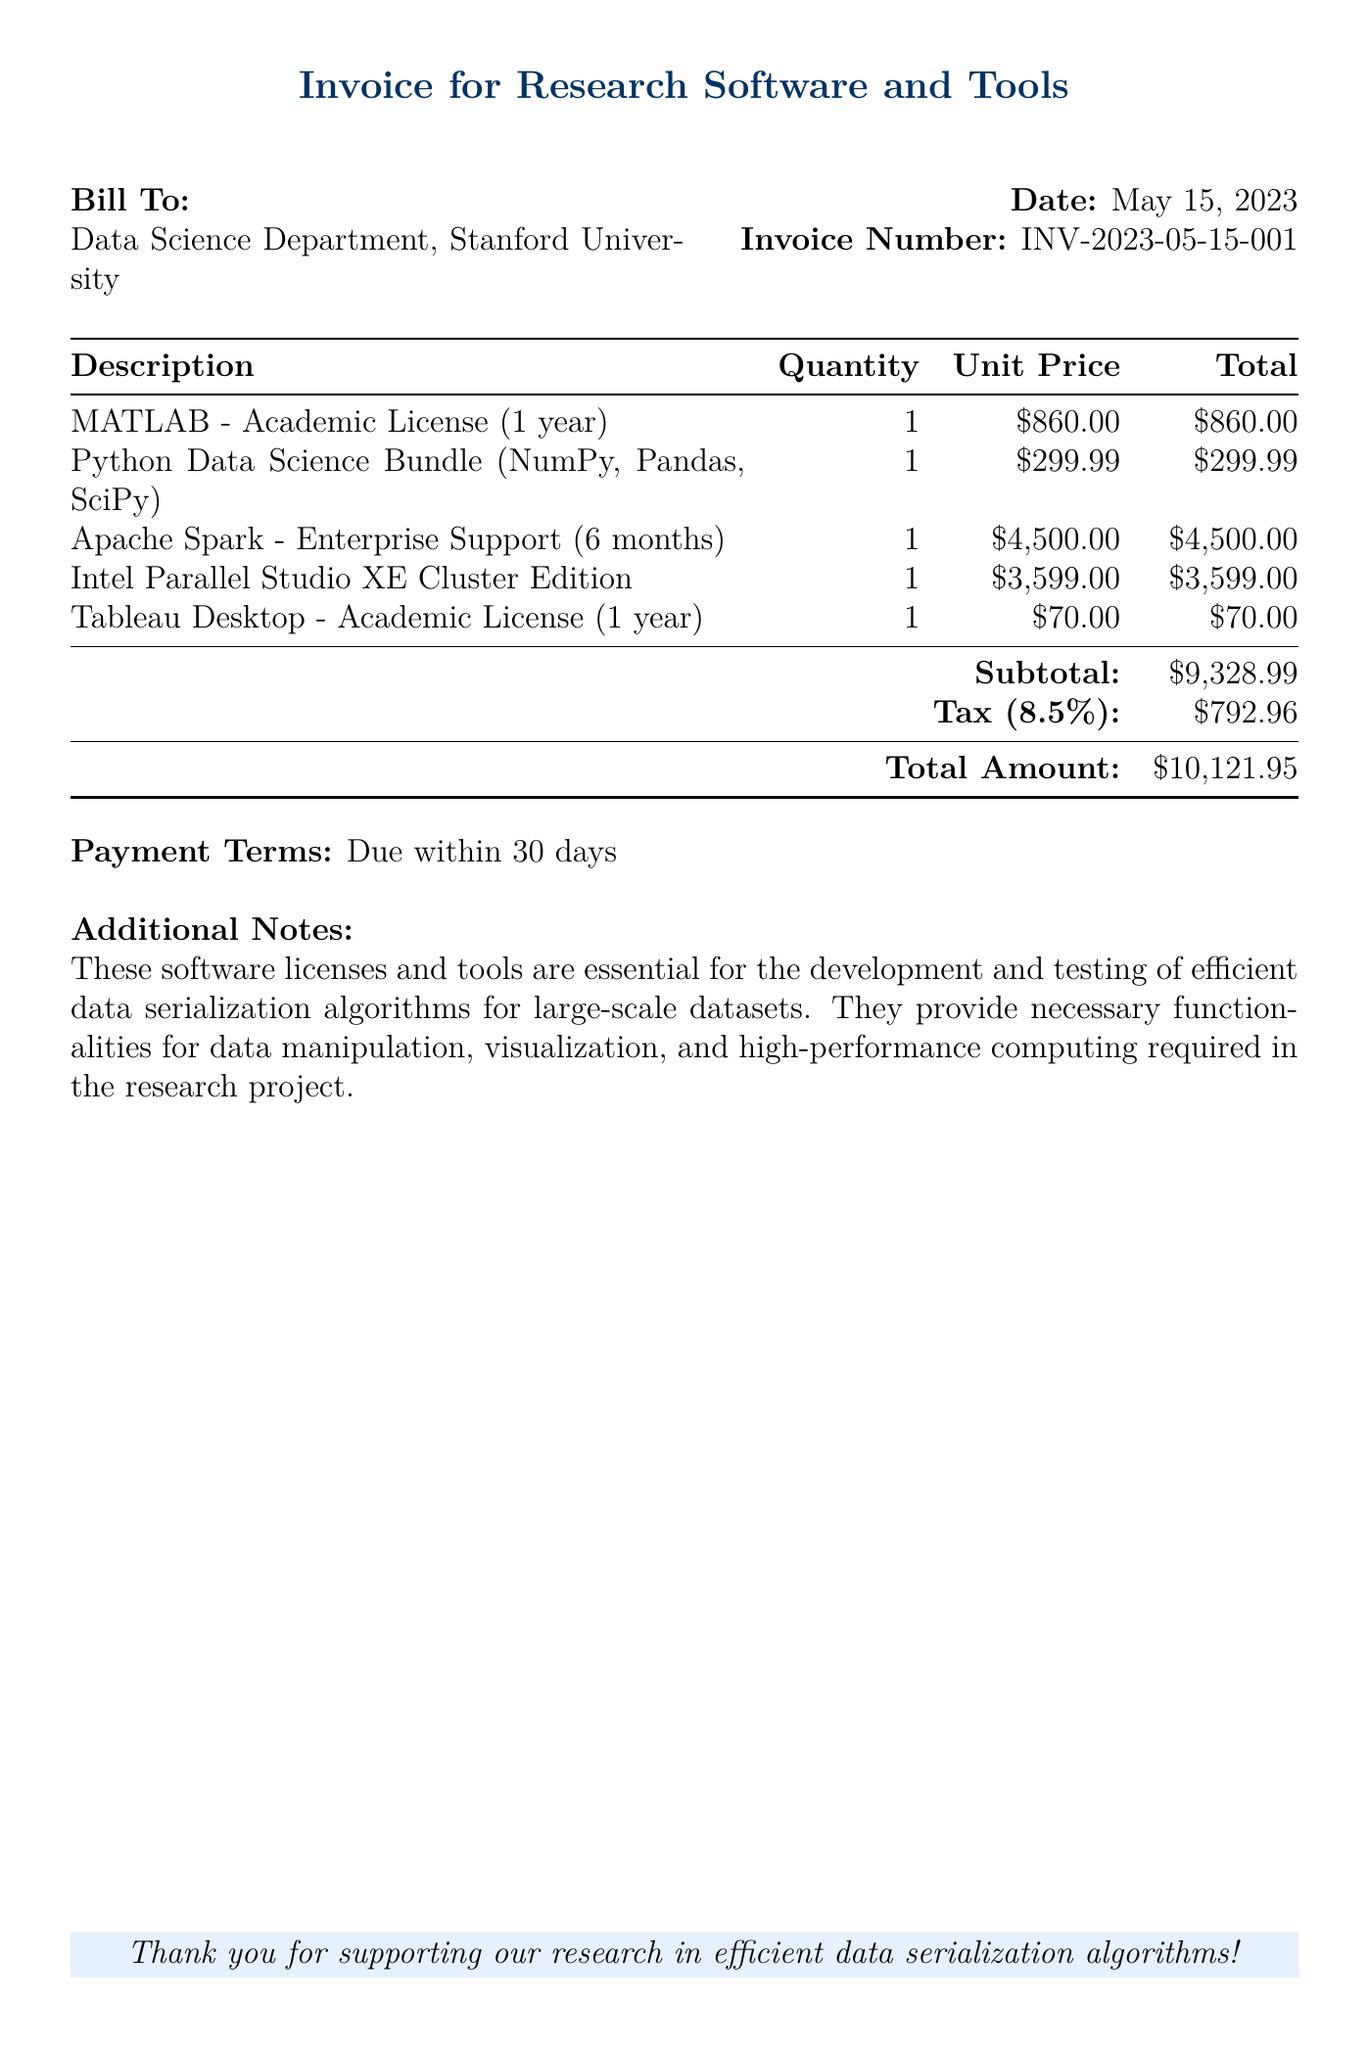what is the invoice date? The document states the date of the invoice is May 15, 2023.
Answer: May 15, 2023 who is the bill addressed to? The bill is addressed to the Data Science Department at Stanford University.
Answer: Data Science Department, Stanford University how much is the unit price for MATLAB? The unit price for MATLAB is clearly listed in the document as $860.00.
Answer: $860.00 what is the subtotal of the bill? The subtotal of the bill, as provided in the document, is the sum of the individual totals before tax.
Answer: $9,328.99 what percentage is the tax on the total? The tax percentage on the total amount specified in the document is given as 8.5%.
Answer: 8.5% how long is the academic license for Tableau Desktop? The document specifies that the academic license for Tableau Desktop is for one year.
Answer: 1 year what is the total amount due? The total amount due at the end of the document is clearly stated as $10,121.95.
Answer: $10,121.95 how soon is the payment due? The payment terms note that the payment is due within 30 days of the invoice date.
Answer: 30 days what is the purpose of the software licenses? The additional notes explain that these software licenses are essential for development and testing of algorithms.
Answer: Development and testing of algorithms 